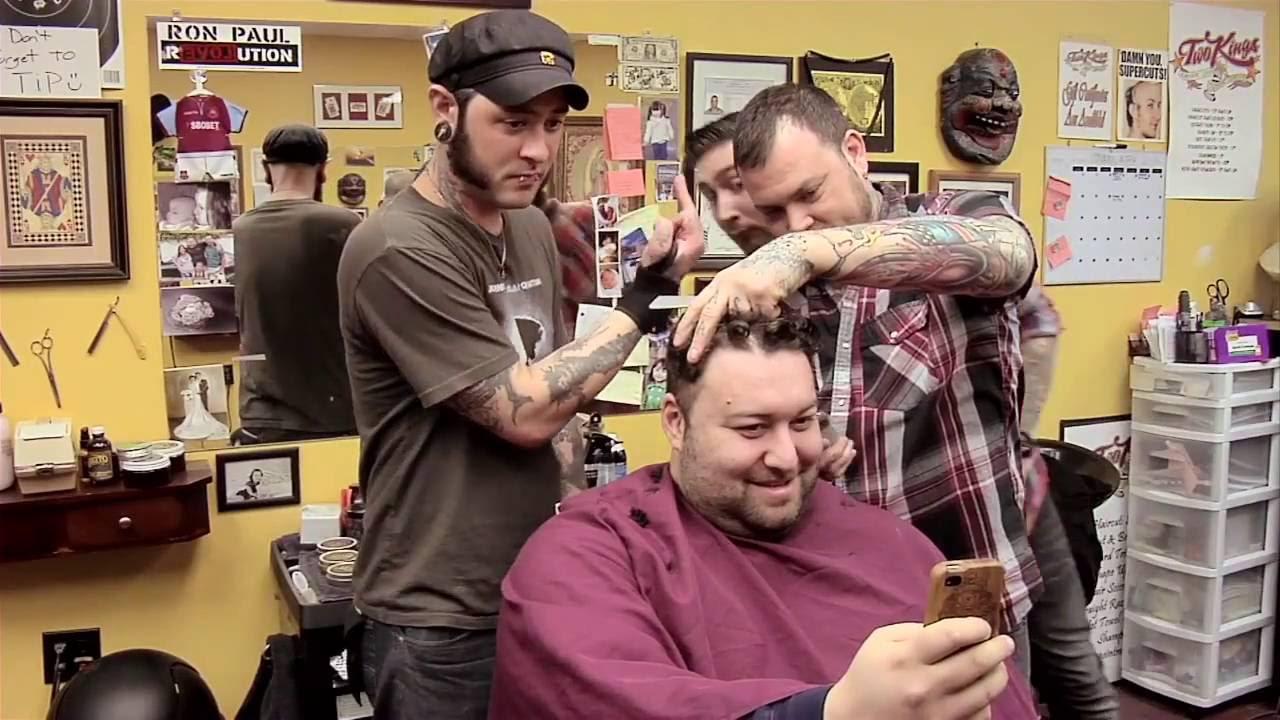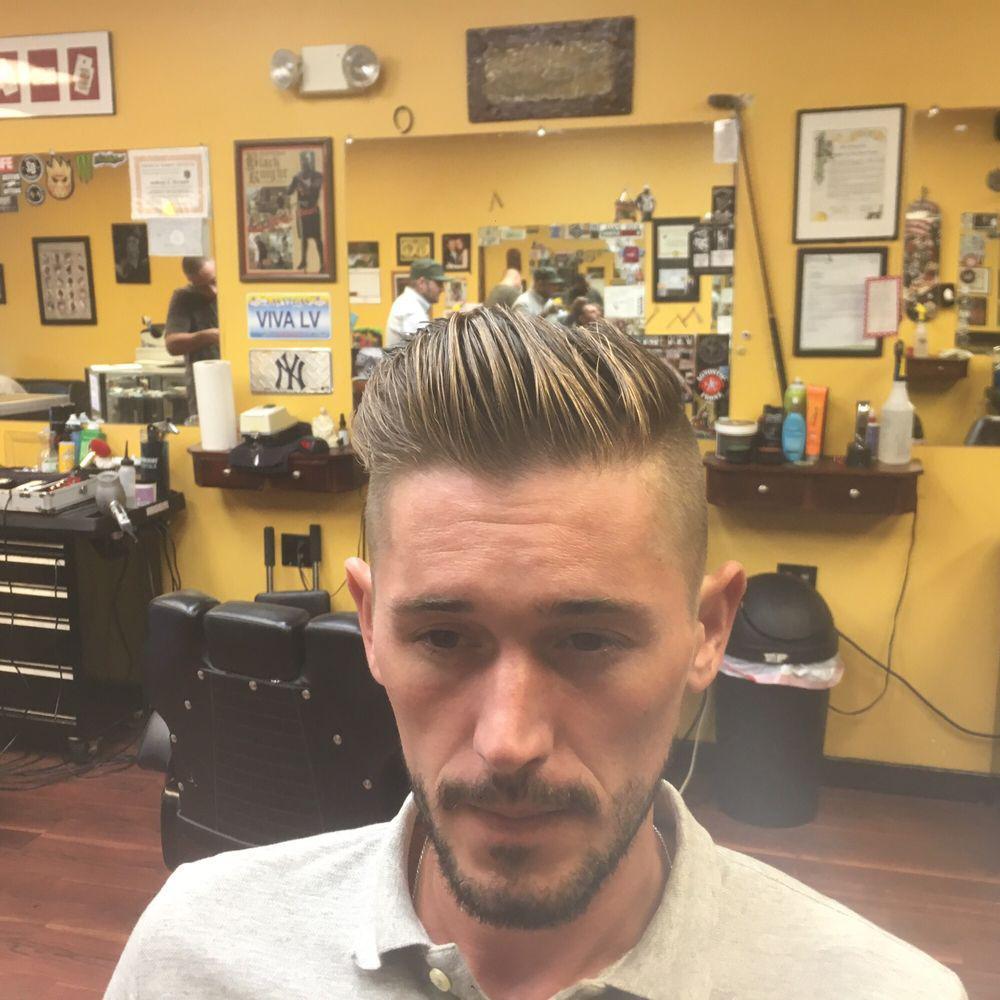The first image is the image on the left, the second image is the image on the right. Given the left and right images, does the statement "An image shows just one young male customer with upswept hair." hold true? Answer yes or no. Yes. 